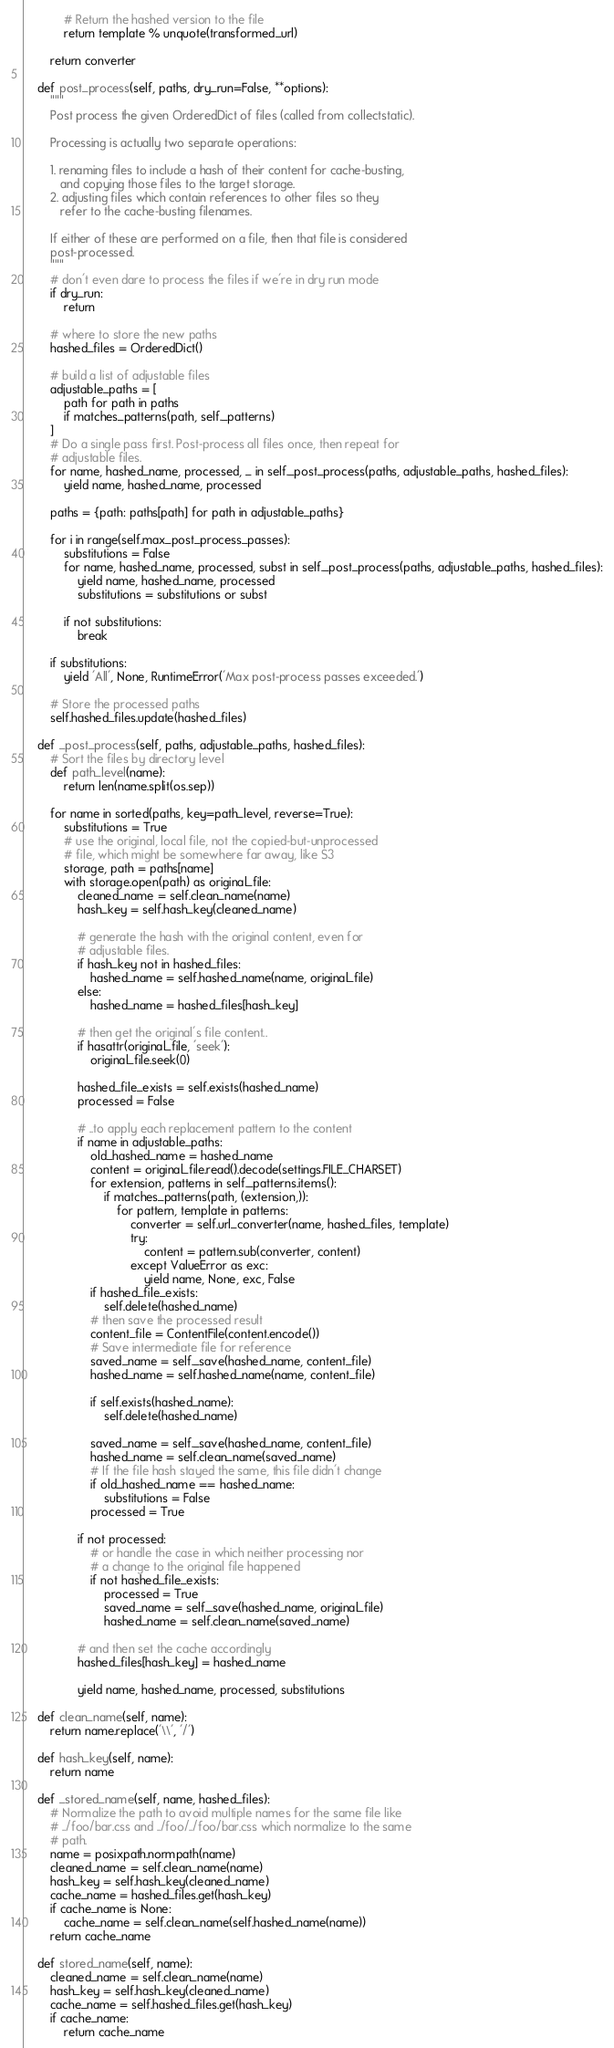<code> <loc_0><loc_0><loc_500><loc_500><_Python_>
            # Return the hashed version to the file
            return template % unquote(transformed_url)

        return converter

    def post_process(self, paths, dry_run=False, **options):
        """
        Post process the given OrderedDict of files (called from collectstatic).

        Processing is actually two separate operations:

        1. renaming files to include a hash of their content for cache-busting,
           and copying those files to the target storage.
        2. adjusting files which contain references to other files so they
           refer to the cache-busting filenames.

        If either of these are performed on a file, then that file is considered
        post-processed.
        """
        # don't even dare to process the files if we're in dry run mode
        if dry_run:
            return

        # where to store the new paths
        hashed_files = OrderedDict()

        # build a list of adjustable files
        adjustable_paths = [
            path for path in paths
            if matches_patterns(path, self._patterns)
        ]
        # Do a single pass first. Post-process all files once, then repeat for
        # adjustable files.
        for name, hashed_name, processed, _ in self._post_process(paths, adjustable_paths, hashed_files):
            yield name, hashed_name, processed

        paths = {path: paths[path] for path in adjustable_paths}

        for i in range(self.max_post_process_passes):
            substitutions = False
            for name, hashed_name, processed, subst in self._post_process(paths, adjustable_paths, hashed_files):
                yield name, hashed_name, processed
                substitutions = substitutions or subst

            if not substitutions:
                break

        if substitutions:
            yield 'All', None, RuntimeError('Max post-process passes exceeded.')

        # Store the processed paths
        self.hashed_files.update(hashed_files)

    def _post_process(self, paths, adjustable_paths, hashed_files):
        # Sort the files by directory level
        def path_level(name):
            return len(name.split(os.sep))

        for name in sorted(paths, key=path_level, reverse=True):
            substitutions = True
            # use the original, local file, not the copied-but-unprocessed
            # file, which might be somewhere far away, like S3
            storage, path = paths[name]
            with storage.open(path) as original_file:
                cleaned_name = self.clean_name(name)
                hash_key = self.hash_key(cleaned_name)

                # generate the hash with the original content, even for
                # adjustable files.
                if hash_key not in hashed_files:
                    hashed_name = self.hashed_name(name, original_file)
                else:
                    hashed_name = hashed_files[hash_key]

                # then get the original's file content..
                if hasattr(original_file, 'seek'):
                    original_file.seek(0)

                hashed_file_exists = self.exists(hashed_name)
                processed = False

                # ..to apply each replacement pattern to the content
                if name in adjustable_paths:
                    old_hashed_name = hashed_name
                    content = original_file.read().decode(settings.FILE_CHARSET)
                    for extension, patterns in self._patterns.items():
                        if matches_patterns(path, (extension,)):
                            for pattern, template in patterns:
                                converter = self.url_converter(name, hashed_files, template)
                                try:
                                    content = pattern.sub(converter, content)
                                except ValueError as exc:
                                    yield name, None, exc, False
                    if hashed_file_exists:
                        self.delete(hashed_name)
                    # then save the processed result
                    content_file = ContentFile(content.encode())
                    # Save intermediate file for reference
                    saved_name = self._save(hashed_name, content_file)
                    hashed_name = self.hashed_name(name, content_file)

                    if self.exists(hashed_name):
                        self.delete(hashed_name)

                    saved_name = self._save(hashed_name, content_file)
                    hashed_name = self.clean_name(saved_name)
                    # If the file hash stayed the same, this file didn't change
                    if old_hashed_name == hashed_name:
                        substitutions = False
                    processed = True

                if not processed:
                    # or handle the case in which neither processing nor
                    # a change to the original file happened
                    if not hashed_file_exists:
                        processed = True
                        saved_name = self._save(hashed_name, original_file)
                        hashed_name = self.clean_name(saved_name)

                # and then set the cache accordingly
                hashed_files[hash_key] = hashed_name

                yield name, hashed_name, processed, substitutions

    def clean_name(self, name):
        return name.replace('\\', '/')

    def hash_key(self, name):
        return name

    def _stored_name(self, name, hashed_files):
        # Normalize the path to avoid multiple names for the same file like
        # ../foo/bar.css and ../foo/../foo/bar.css which normalize to the same
        # path.
        name = posixpath.normpath(name)
        cleaned_name = self.clean_name(name)
        hash_key = self.hash_key(cleaned_name)
        cache_name = hashed_files.get(hash_key)
        if cache_name is None:
            cache_name = self.clean_name(self.hashed_name(name))
        return cache_name

    def stored_name(self, name):
        cleaned_name = self.clean_name(name)
        hash_key = self.hash_key(cleaned_name)
        cache_name = self.hashed_files.get(hash_key)
        if cache_name:
            return cache_name</code> 